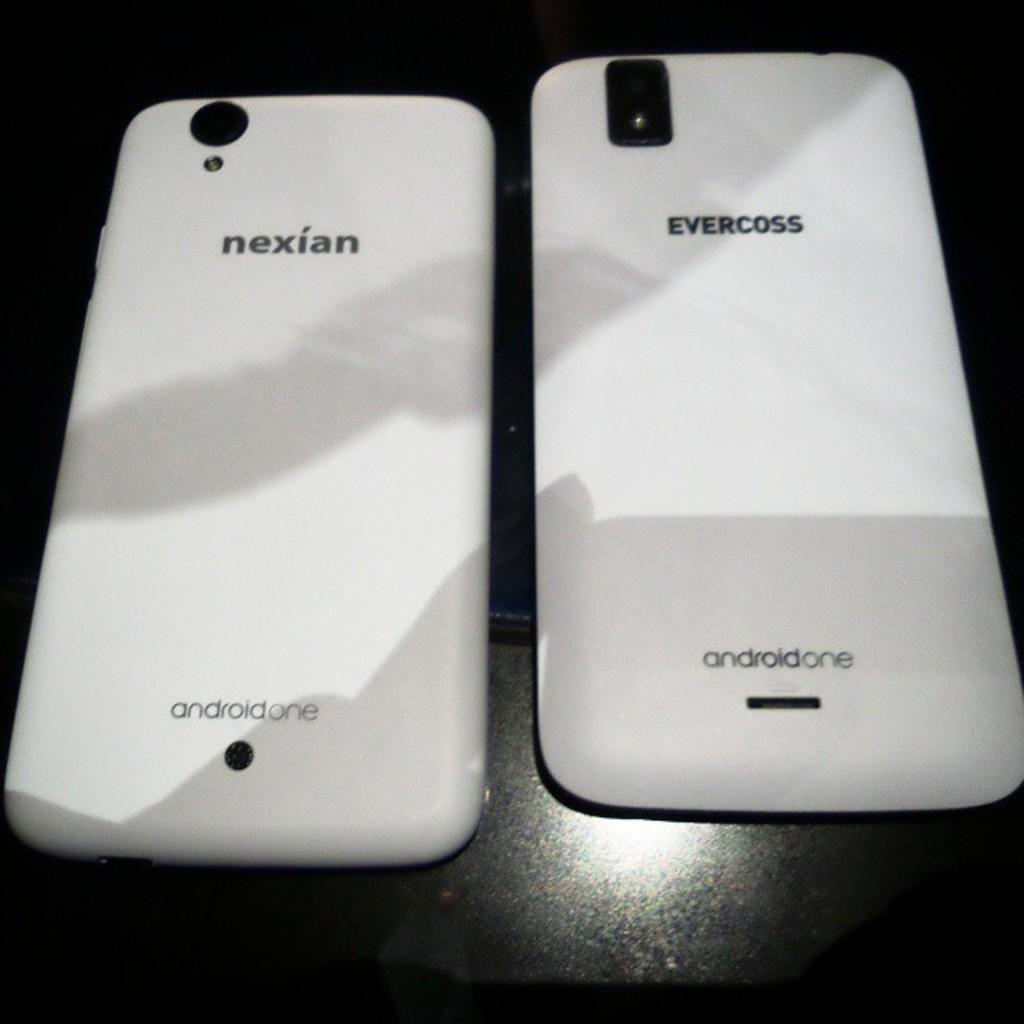What kind of cell phone is on the right?
Ensure brevity in your answer.  Evercross. 